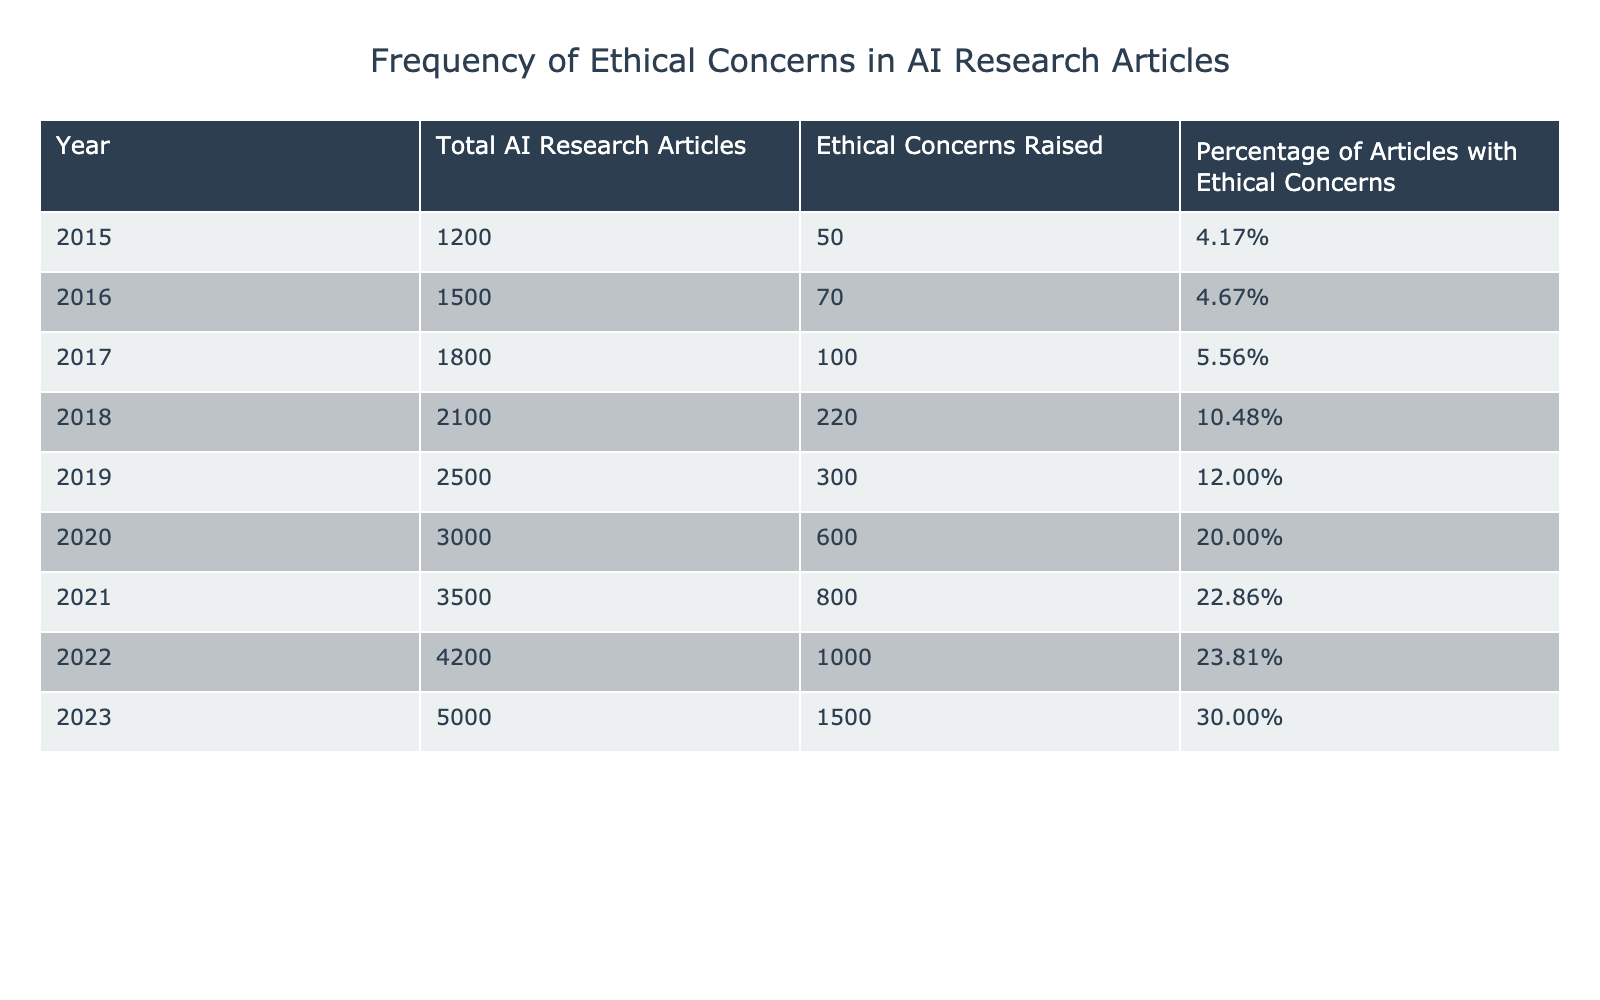What's the percentage of AI research articles with ethical concerns in 2023? In 2023, the table shows that the percentage of articles with ethical concerns is 30.00%.
Answer: 30.00% How many ethical concerns were raised in AI research articles in 2020? According to the table, there were 600 ethical concerns raised in AI research articles in 2020.
Answer: 600 What was the total number of AI research articles published in 2019? In 2019, the table indicates that a total of 2500 AI research articles were published.
Answer: 2500 Which year had the highest number of articles with ethical concerns? By examining the data, we see 2023 had the highest number of ethical concerns raised, with 1500 concerns.
Answer: 2023 How many more ethical concerns were raised in 2021 compared to 2015? The table states that in 2021, there were 800 concerns, and in 2015 there were 50. The difference is 800 - 50 = 750 concerns.
Answer: 750 What is the average percentage of ethical concerns in AI research articles from 2015 to 2023? To find the average percentage, we add the percentages for each year (4.17 + 4.67 + 5.56 + 10.48 + 12.00 + 20.00 + 22.86 + 23.81 + 30.00 = 133.55) and divide by the number of years (9), resulting in approximately 14.84%.
Answer: 14.84% Was the percentage of articles with ethical concerns higher in 2022 than in 2021? The table shows 23.81% in 2022 and 22.86% in 2021, indicating that 2022 indeed had a higher percentage.
Answer: Yes If the trend continues, what is the expected number of ethical concerns in 2024 based on the increase from 2023? From 2022 to 2023, the increase was 500 concerns (1500 - 1000). If this trend continues, we expect 2000 ethical concerns in 2024 (1500 + 500).
Answer: 2000 What is the ratio of ethical concerns raised in 2020 to those raised in 2018? In 2020, there were 600 concerns and in 2018, there were 220 concerns. The ratio is 600:220, which simplifies to approximately 2.73:1.
Answer: 2.73:1 How many total ethical concerns were raised in AI research articles from 2015 to 2020? Adding up all ethical concerns from each year (50 + 70 + 100 + 220 + 300 + 600) gives a total of 1340 concerns raised from 2015 to 2020.
Answer: 1340 